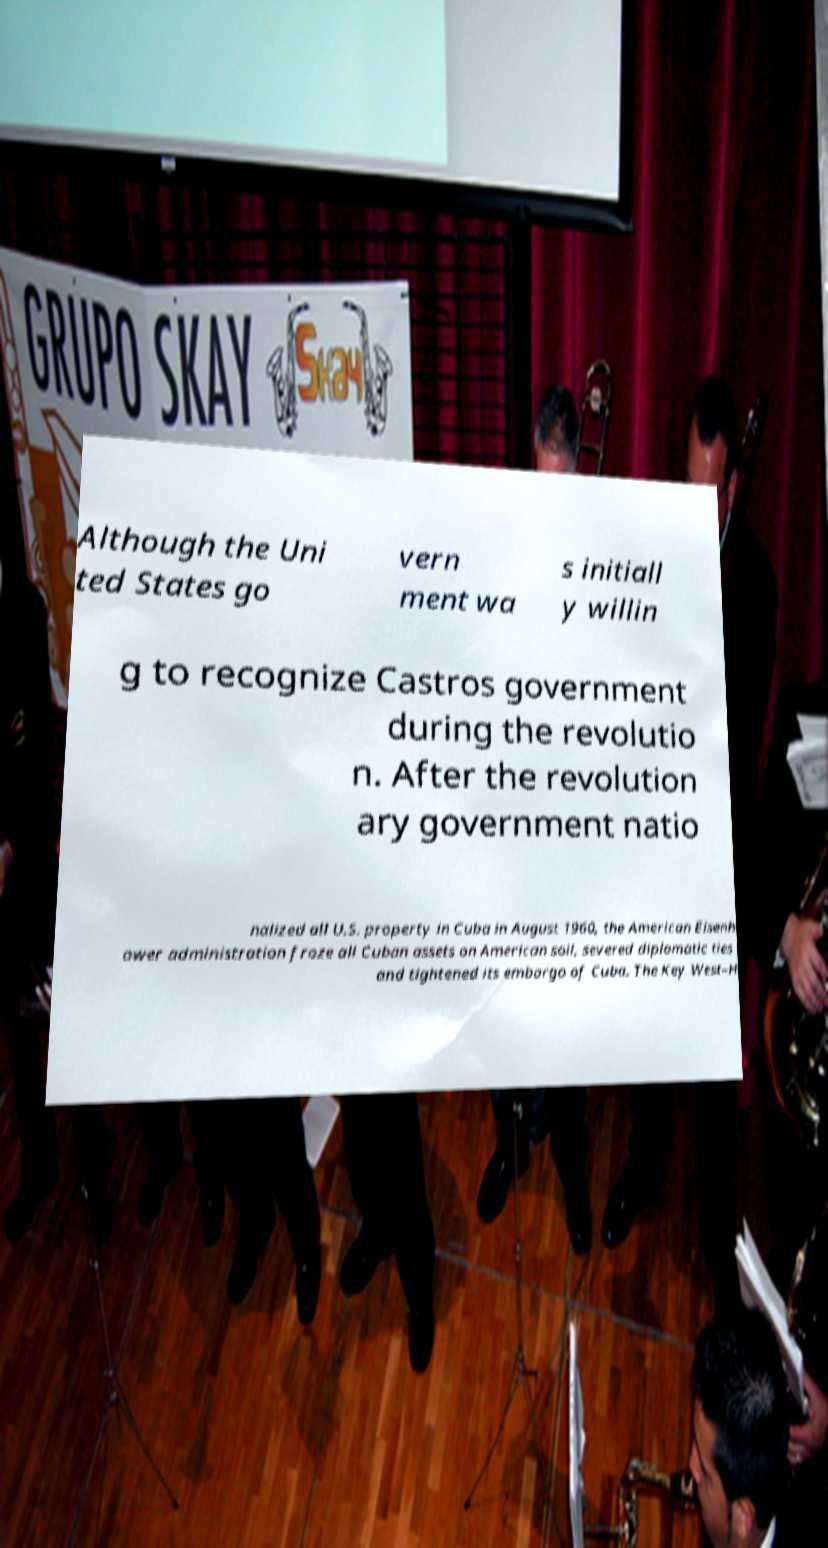Can you read and provide the text displayed in the image?This photo seems to have some interesting text. Can you extract and type it out for me? Although the Uni ted States go vern ment wa s initiall y willin g to recognize Castros government during the revolutio n. After the revolution ary government natio nalized all U.S. property in Cuba in August 1960, the American Eisenh ower administration froze all Cuban assets on American soil, severed diplomatic ties and tightened its embargo of Cuba. The Key West–H 